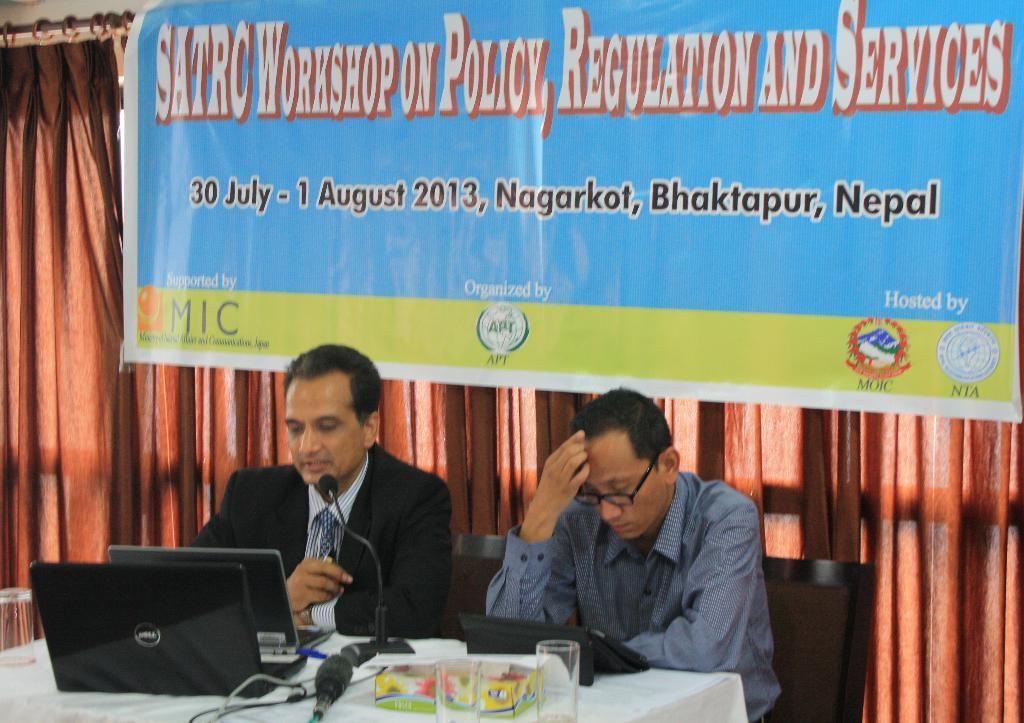What type of fabric is hanging in the image? There is a curtain in the image. What is hanging next to the curtain? There is a banner in the image. How many people are sitting in the image? There are two persons sitting on chairs in the image. What is on the table in the image? There is a glass, a book, laptops, and a microphone on the table. What type of pest can be seen crawling on the banner in the image? There are no pests visible in the image; it only features a curtain, a banner, chairs, a table, a glass, a book, laptops, and a microphone. What type of dental treatment is being performed on the person sitting on the left chair in the image? There is no dental treatment being performed in the image; the two persons are simply sitting on chairs. 